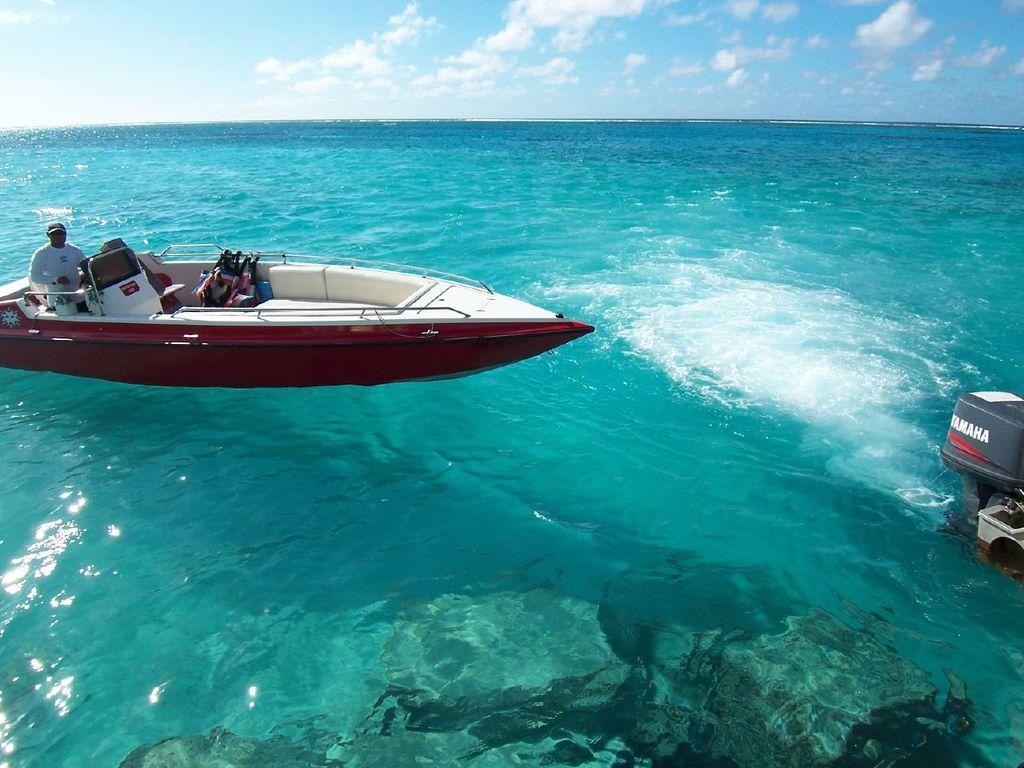Describe this image in one or two sentences. In this image I can see an ocean. On the left side there is a boat and one person is standing on the boat. On the right side, I can see an engine of another boat. At the top of the image I can see the sky and clouds. 